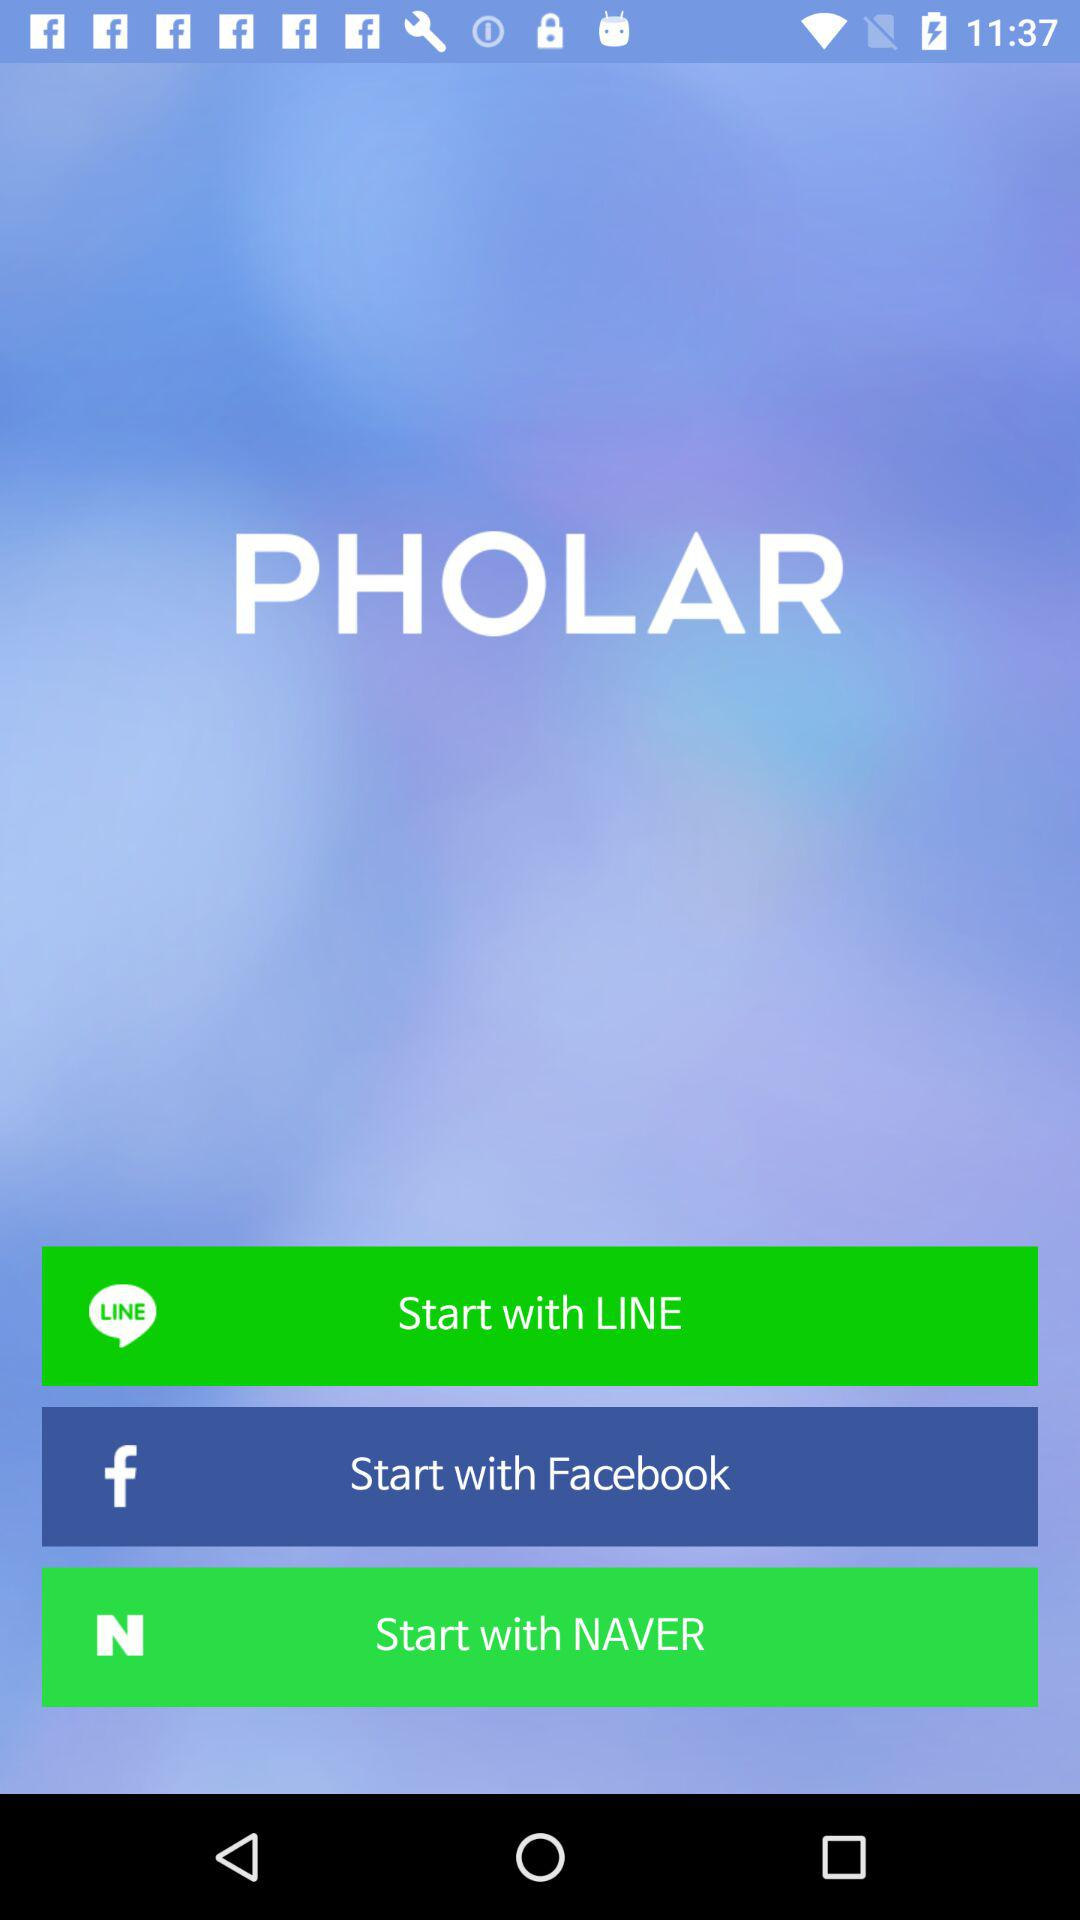What are the different applications through which we can get started? The different applications are "LINE", "Facebook" and "NAVER". 